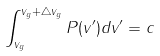<formula> <loc_0><loc_0><loc_500><loc_500>\int _ { v _ { g } } ^ { v _ { g } + \triangle v _ { g } } P ( v ^ { \prime } ) d v ^ { \prime } = c</formula> 